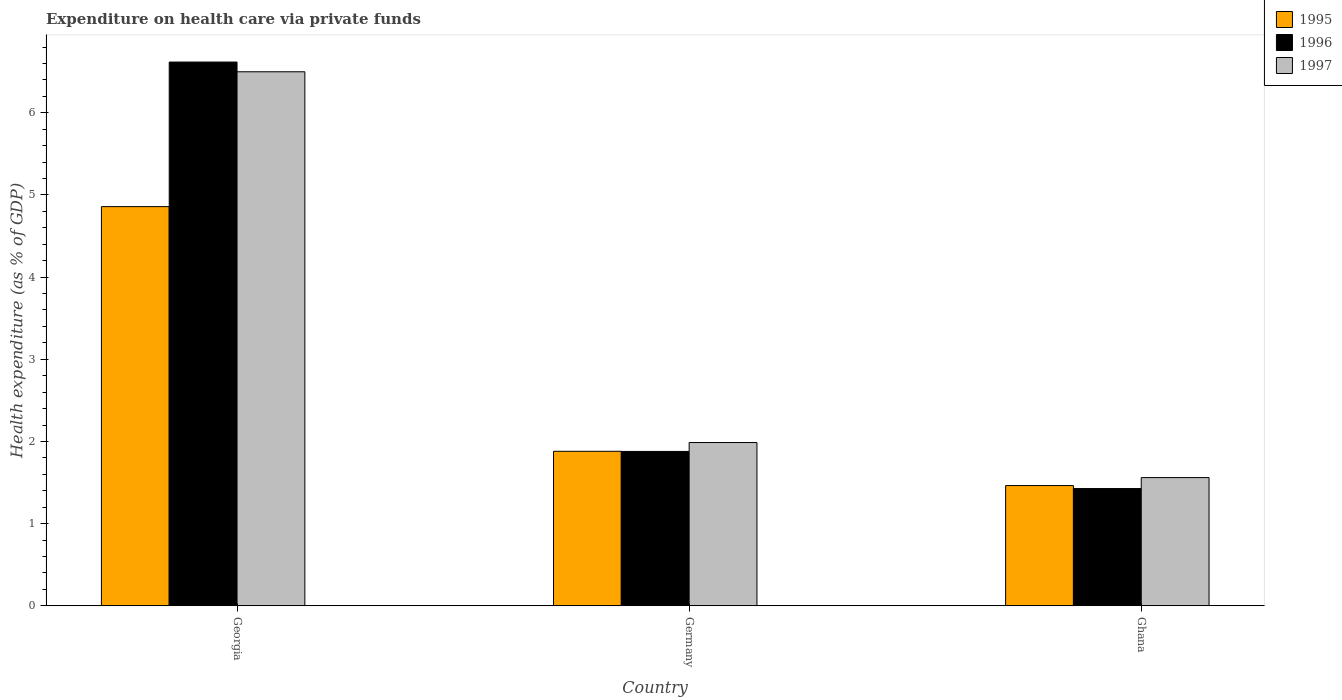How many different coloured bars are there?
Ensure brevity in your answer.  3. How many groups of bars are there?
Keep it short and to the point. 3. Are the number of bars per tick equal to the number of legend labels?
Keep it short and to the point. Yes. How many bars are there on the 1st tick from the left?
Your answer should be compact. 3. What is the label of the 1st group of bars from the left?
Your response must be concise. Georgia. In how many cases, is the number of bars for a given country not equal to the number of legend labels?
Keep it short and to the point. 0. What is the expenditure made on health care in 1996 in Ghana?
Offer a terse response. 1.43. Across all countries, what is the maximum expenditure made on health care in 1996?
Your answer should be compact. 6.62. Across all countries, what is the minimum expenditure made on health care in 1995?
Your answer should be very brief. 1.46. In which country was the expenditure made on health care in 1996 maximum?
Your answer should be compact. Georgia. What is the total expenditure made on health care in 1995 in the graph?
Your response must be concise. 8.2. What is the difference between the expenditure made on health care in 1996 in Germany and that in Ghana?
Offer a terse response. 0.45. What is the difference between the expenditure made on health care in 1996 in Germany and the expenditure made on health care in 1997 in Ghana?
Your response must be concise. 0.32. What is the average expenditure made on health care in 1996 per country?
Provide a succinct answer. 3.31. What is the difference between the expenditure made on health care of/in 1995 and expenditure made on health care of/in 1997 in Ghana?
Your answer should be compact. -0.1. What is the ratio of the expenditure made on health care in 1995 in Germany to that in Ghana?
Make the answer very short. 1.29. Is the expenditure made on health care in 1995 in Germany less than that in Ghana?
Offer a very short reply. No. Is the difference between the expenditure made on health care in 1995 in Georgia and Ghana greater than the difference between the expenditure made on health care in 1997 in Georgia and Ghana?
Provide a succinct answer. No. What is the difference between the highest and the second highest expenditure made on health care in 1996?
Your answer should be very brief. 0.45. What is the difference between the highest and the lowest expenditure made on health care in 1996?
Make the answer very short. 5.19. Is the sum of the expenditure made on health care in 1995 in Georgia and Ghana greater than the maximum expenditure made on health care in 1996 across all countries?
Make the answer very short. No. How many bars are there?
Offer a very short reply. 9. How many countries are there in the graph?
Provide a succinct answer. 3. Are the values on the major ticks of Y-axis written in scientific E-notation?
Give a very brief answer. No. Where does the legend appear in the graph?
Offer a very short reply. Top right. What is the title of the graph?
Your answer should be very brief. Expenditure on health care via private funds. What is the label or title of the Y-axis?
Your answer should be very brief. Health expenditure (as % of GDP). What is the Health expenditure (as % of GDP) of 1995 in Georgia?
Your answer should be compact. 4.86. What is the Health expenditure (as % of GDP) of 1996 in Georgia?
Offer a very short reply. 6.62. What is the Health expenditure (as % of GDP) in 1997 in Georgia?
Provide a short and direct response. 6.5. What is the Health expenditure (as % of GDP) in 1995 in Germany?
Your response must be concise. 1.88. What is the Health expenditure (as % of GDP) of 1996 in Germany?
Offer a terse response. 1.88. What is the Health expenditure (as % of GDP) in 1997 in Germany?
Provide a short and direct response. 1.99. What is the Health expenditure (as % of GDP) in 1995 in Ghana?
Keep it short and to the point. 1.46. What is the Health expenditure (as % of GDP) in 1996 in Ghana?
Give a very brief answer. 1.43. What is the Health expenditure (as % of GDP) in 1997 in Ghana?
Your answer should be very brief. 1.56. Across all countries, what is the maximum Health expenditure (as % of GDP) in 1995?
Your response must be concise. 4.86. Across all countries, what is the maximum Health expenditure (as % of GDP) of 1996?
Keep it short and to the point. 6.62. Across all countries, what is the maximum Health expenditure (as % of GDP) in 1997?
Ensure brevity in your answer.  6.5. Across all countries, what is the minimum Health expenditure (as % of GDP) in 1995?
Provide a succinct answer. 1.46. Across all countries, what is the minimum Health expenditure (as % of GDP) of 1996?
Your response must be concise. 1.43. Across all countries, what is the minimum Health expenditure (as % of GDP) of 1997?
Your response must be concise. 1.56. What is the total Health expenditure (as % of GDP) of 1995 in the graph?
Provide a succinct answer. 8.2. What is the total Health expenditure (as % of GDP) of 1996 in the graph?
Your answer should be compact. 9.92. What is the total Health expenditure (as % of GDP) in 1997 in the graph?
Your answer should be compact. 10.05. What is the difference between the Health expenditure (as % of GDP) of 1995 in Georgia and that in Germany?
Give a very brief answer. 2.98. What is the difference between the Health expenditure (as % of GDP) in 1996 in Georgia and that in Germany?
Keep it short and to the point. 4.74. What is the difference between the Health expenditure (as % of GDP) in 1997 in Georgia and that in Germany?
Keep it short and to the point. 4.51. What is the difference between the Health expenditure (as % of GDP) of 1995 in Georgia and that in Ghana?
Provide a short and direct response. 3.39. What is the difference between the Health expenditure (as % of GDP) in 1996 in Georgia and that in Ghana?
Keep it short and to the point. 5.19. What is the difference between the Health expenditure (as % of GDP) of 1997 in Georgia and that in Ghana?
Your answer should be compact. 4.94. What is the difference between the Health expenditure (as % of GDP) of 1995 in Germany and that in Ghana?
Give a very brief answer. 0.42. What is the difference between the Health expenditure (as % of GDP) of 1996 in Germany and that in Ghana?
Keep it short and to the point. 0.45. What is the difference between the Health expenditure (as % of GDP) in 1997 in Germany and that in Ghana?
Keep it short and to the point. 0.43. What is the difference between the Health expenditure (as % of GDP) in 1995 in Georgia and the Health expenditure (as % of GDP) in 1996 in Germany?
Keep it short and to the point. 2.98. What is the difference between the Health expenditure (as % of GDP) in 1995 in Georgia and the Health expenditure (as % of GDP) in 1997 in Germany?
Offer a terse response. 2.87. What is the difference between the Health expenditure (as % of GDP) in 1996 in Georgia and the Health expenditure (as % of GDP) in 1997 in Germany?
Offer a very short reply. 4.63. What is the difference between the Health expenditure (as % of GDP) of 1995 in Georgia and the Health expenditure (as % of GDP) of 1996 in Ghana?
Provide a succinct answer. 3.43. What is the difference between the Health expenditure (as % of GDP) in 1995 in Georgia and the Health expenditure (as % of GDP) in 1997 in Ghana?
Offer a very short reply. 3.3. What is the difference between the Health expenditure (as % of GDP) in 1996 in Georgia and the Health expenditure (as % of GDP) in 1997 in Ghana?
Ensure brevity in your answer.  5.06. What is the difference between the Health expenditure (as % of GDP) of 1995 in Germany and the Health expenditure (as % of GDP) of 1996 in Ghana?
Keep it short and to the point. 0.45. What is the difference between the Health expenditure (as % of GDP) of 1995 in Germany and the Health expenditure (as % of GDP) of 1997 in Ghana?
Your response must be concise. 0.32. What is the difference between the Health expenditure (as % of GDP) of 1996 in Germany and the Health expenditure (as % of GDP) of 1997 in Ghana?
Ensure brevity in your answer.  0.32. What is the average Health expenditure (as % of GDP) in 1995 per country?
Provide a succinct answer. 2.73. What is the average Health expenditure (as % of GDP) of 1996 per country?
Ensure brevity in your answer.  3.31. What is the average Health expenditure (as % of GDP) in 1997 per country?
Offer a terse response. 3.35. What is the difference between the Health expenditure (as % of GDP) in 1995 and Health expenditure (as % of GDP) in 1996 in Georgia?
Your answer should be compact. -1.76. What is the difference between the Health expenditure (as % of GDP) in 1995 and Health expenditure (as % of GDP) in 1997 in Georgia?
Offer a terse response. -1.64. What is the difference between the Health expenditure (as % of GDP) of 1996 and Health expenditure (as % of GDP) of 1997 in Georgia?
Offer a terse response. 0.12. What is the difference between the Health expenditure (as % of GDP) in 1995 and Health expenditure (as % of GDP) in 1996 in Germany?
Make the answer very short. 0. What is the difference between the Health expenditure (as % of GDP) of 1995 and Health expenditure (as % of GDP) of 1997 in Germany?
Ensure brevity in your answer.  -0.11. What is the difference between the Health expenditure (as % of GDP) of 1996 and Health expenditure (as % of GDP) of 1997 in Germany?
Provide a short and direct response. -0.11. What is the difference between the Health expenditure (as % of GDP) of 1995 and Health expenditure (as % of GDP) of 1996 in Ghana?
Ensure brevity in your answer.  0.04. What is the difference between the Health expenditure (as % of GDP) in 1995 and Health expenditure (as % of GDP) in 1997 in Ghana?
Offer a terse response. -0.1. What is the difference between the Health expenditure (as % of GDP) of 1996 and Health expenditure (as % of GDP) of 1997 in Ghana?
Your response must be concise. -0.13. What is the ratio of the Health expenditure (as % of GDP) in 1995 in Georgia to that in Germany?
Provide a succinct answer. 2.58. What is the ratio of the Health expenditure (as % of GDP) in 1996 in Georgia to that in Germany?
Ensure brevity in your answer.  3.52. What is the ratio of the Health expenditure (as % of GDP) of 1997 in Georgia to that in Germany?
Your response must be concise. 3.27. What is the ratio of the Health expenditure (as % of GDP) in 1995 in Georgia to that in Ghana?
Your answer should be compact. 3.32. What is the ratio of the Health expenditure (as % of GDP) of 1996 in Georgia to that in Ghana?
Provide a succinct answer. 4.64. What is the ratio of the Health expenditure (as % of GDP) in 1997 in Georgia to that in Ghana?
Provide a short and direct response. 4.17. What is the ratio of the Health expenditure (as % of GDP) of 1995 in Germany to that in Ghana?
Your response must be concise. 1.29. What is the ratio of the Health expenditure (as % of GDP) of 1996 in Germany to that in Ghana?
Offer a very short reply. 1.32. What is the ratio of the Health expenditure (as % of GDP) in 1997 in Germany to that in Ghana?
Give a very brief answer. 1.27. What is the difference between the highest and the second highest Health expenditure (as % of GDP) in 1995?
Your answer should be very brief. 2.98. What is the difference between the highest and the second highest Health expenditure (as % of GDP) in 1996?
Offer a terse response. 4.74. What is the difference between the highest and the second highest Health expenditure (as % of GDP) of 1997?
Provide a succinct answer. 4.51. What is the difference between the highest and the lowest Health expenditure (as % of GDP) of 1995?
Give a very brief answer. 3.39. What is the difference between the highest and the lowest Health expenditure (as % of GDP) in 1996?
Keep it short and to the point. 5.19. What is the difference between the highest and the lowest Health expenditure (as % of GDP) of 1997?
Give a very brief answer. 4.94. 